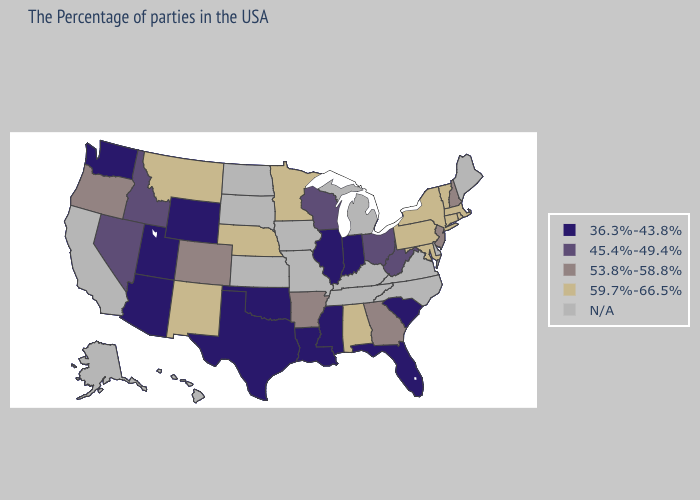Name the states that have a value in the range 53.8%-58.8%?
Write a very short answer. New Hampshire, New Jersey, Georgia, Arkansas, Colorado, Oregon. Does Massachusetts have the highest value in the Northeast?
Short answer required. Yes. Does Utah have the lowest value in the USA?
Short answer required. Yes. What is the value of Kentucky?
Quick response, please. N/A. Which states have the lowest value in the West?
Answer briefly. Wyoming, Utah, Arizona, Washington. Name the states that have a value in the range 36.3%-43.8%?
Be succinct. South Carolina, Florida, Indiana, Illinois, Mississippi, Louisiana, Oklahoma, Texas, Wyoming, Utah, Arizona, Washington. What is the value of Nevada?
Concise answer only. 45.4%-49.4%. Which states hav the highest value in the MidWest?
Quick response, please. Minnesota, Nebraska. Which states have the lowest value in the West?
Short answer required. Wyoming, Utah, Arizona, Washington. How many symbols are there in the legend?
Write a very short answer. 5. What is the value of North Carolina?
Give a very brief answer. N/A. Does the map have missing data?
Answer briefly. Yes. Name the states that have a value in the range 36.3%-43.8%?
Write a very short answer. South Carolina, Florida, Indiana, Illinois, Mississippi, Louisiana, Oklahoma, Texas, Wyoming, Utah, Arizona, Washington. Name the states that have a value in the range 53.8%-58.8%?
Write a very short answer. New Hampshire, New Jersey, Georgia, Arkansas, Colorado, Oregon. 